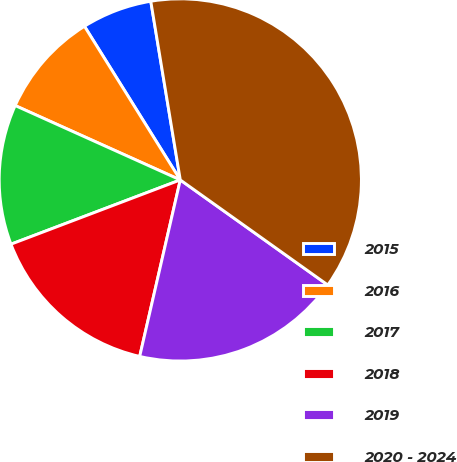Convert chart. <chart><loc_0><loc_0><loc_500><loc_500><pie_chart><fcel>2015<fcel>2016<fcel>2017<fcel>2018<fcel>2019<fcel>2020 - 2024<nl><fcel>6.27%<fcel>9.39%<fcel>12.51%<fcel>15.63%<fcel>18.75%<fcel>37.46%<nl></chart> 